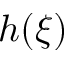<formula> <loc_0><loc_0><loc_500><loc_500>h ( \xi )</formula> 